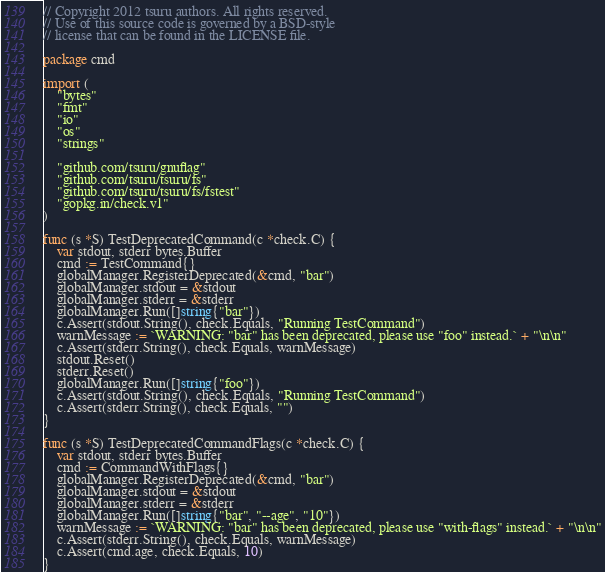Convert code to text. <code><loc_0><loc_0><loc_500><loc_500><_Go_>// Copyright 2012 tsuru authors. All rights reserved.
// Use of this source code is governed by a BSD-style
// license that can be found in the LICENSE file.

package cmd

import (
	"bytes"
	"fmt"
	"io"
	"os"
	"strings"

	"github.com/tsuru/gnuflag"
	"github.com/tsuru/tsuru/fs"
	"github.com/tsuru/tsuru/fs/fstest"
	"gopkg.in/check.v1"
)

func (s *S) TestDeprecatedCommand(c *check.C) {
	var stdout, stderr bytes.Buffer
	cmd := TestCommand{}
	globalManager.RegisterDeprecated(&cmd, "bar")
	globalManager.stdout = &stdout
	globalManager.stderr = &stderr
	globalManager.Run([]string{"bar"})
	c.Assert(stdout.String(), check.Equals, "Running TestCommand")
	warnMessage := `WARNING: "bar" has been deprecated, please use "foo" instead.` + "\n\n"
	c.Assert(stderr.String(), check.Equals, warnMessage)
	stdout.Reset()
	stderr.Reset()
	globalManager.Run([]string{"foo"})
	c.Assert(stdout.String(), check.Equals, "Running TestCommand")
	c.Assert(stderr.String(), check.Equals, "")
}

func (s *S) TestDeprecatedCommandFlags(c *check.C) {
	var stdout, stderr bytes.Buffer
	cmd := CommandWithFlags{}
	globalManager.RegisterDeprecated(&cmd, "bar")
	globalManager.stdout = &stdout
	globalManager.stderr = &stderr
	globalManager.Run([]string{"bar", "--age", "10"})
	warnMessage := `WARNING: "bar" has been deprecated, please use "with-flags" instead.` + "\n\n"
	c.Assert(stderr.String(), check.Equals, warnMessage)
	c.Assert(cmd.age, check.Equals, 10)
}
</code> 